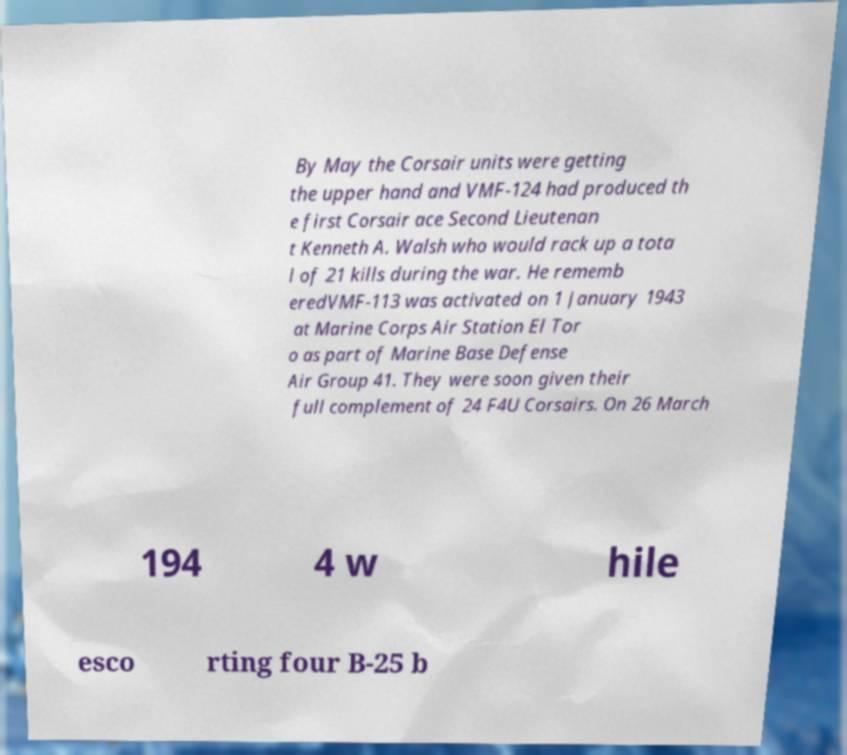Can you accurately transcribe the text from the provided image for me? By May the Corsair units were getting the upper hand and VMF-124 had produced th e first Corsair ace Second Lieutenan t Kenneth A. Walsh who would rack up a tota l of 21 kills during the war. He rememb eredVMF-113 was activated on 1 January 1943 at Marine Corps Air Station El Tor o as part of Marine Base Defense Air Group 41. They were soon given their full complement of 24 F4U Corsairs. On 26 March 194 4 w hile esco rting four B-25 b 